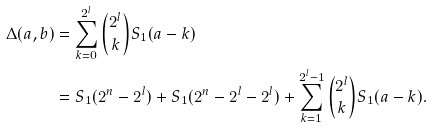Convert formula to latex. <formula><loc_0><loc_0><loc_500><loc_500>\Delta ( a , b ) & = \sum _ { k = 0 } ^ { 2 ^ { l } } \binom { 2 ^ { l } } { k } S _ { 1 } ( a - k ) \\ & = S _ { 1 } ( 2 ^ { n } - 2 ^ { l } ) + S _ { 1 } ( 2 ^ { n } - 2 ^ { l } - 2 ^ { l } ) + \sum _ { k = 1 } ^ { 2 ^ { l } - 1 } \binom { 2 ^ { l } } { k } S _ { 1 } ( a - k ) .</formula> 